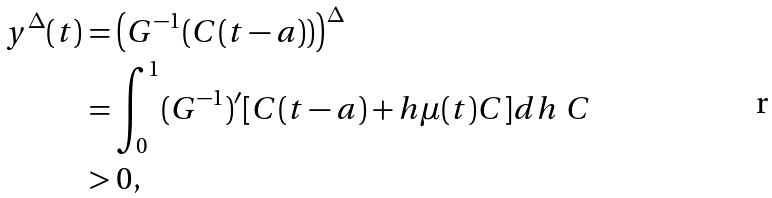Convert formula to latex. <formula><loc_0><loc_0><loc_500><loc_500>y ^ { \Delta } ( t ) & = \left ( G ^ { - 1 } ( C ( t - a ) ) \right ) ^ { \Delta } \\ & = \int _ { 0 } ^ { 1 } ( G ^ { - 1 } ) ^ { \prime } [ C ( t - a ) + h \mu ( t ) C ] d h \ C \\ & > 0 ,</formula> 